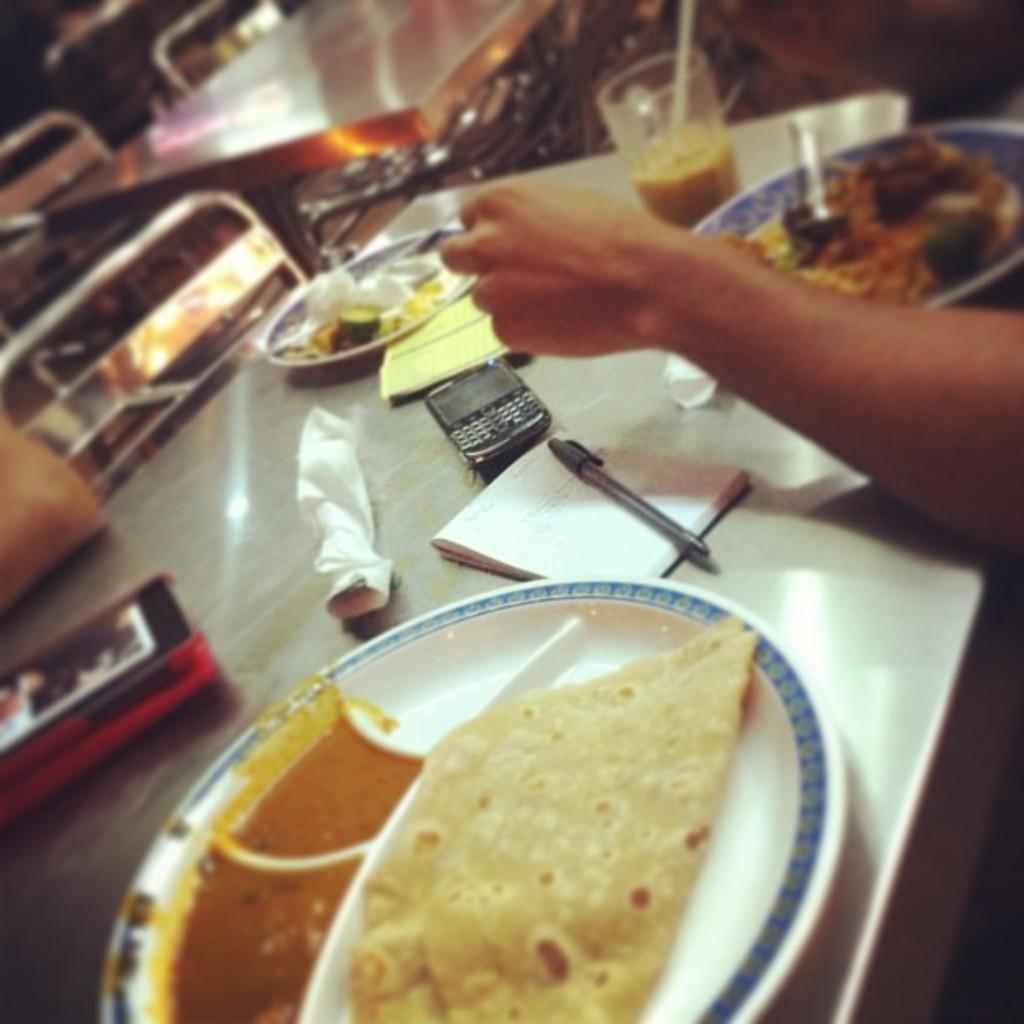Can you describe this image briefly? In this image I can see few tables, few chairs, hand of a person, a notebook, a pen, a phone, a glass, few plates, few tissue papers and different types of food. I can also see an object over here. 